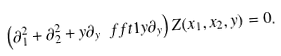<formula> <loc_0><loc_0><loc_500><loc_500>\left ( \partial _ { 1 } ^ { 2 } + \partial _ { 2 } ^ { 2 } + y \partial _ { y } \ f f t 1 y \partial _ { y } \right ) Z ( x _ { 1 } , x _ { 2 } , y ) = 0 .</formula> 